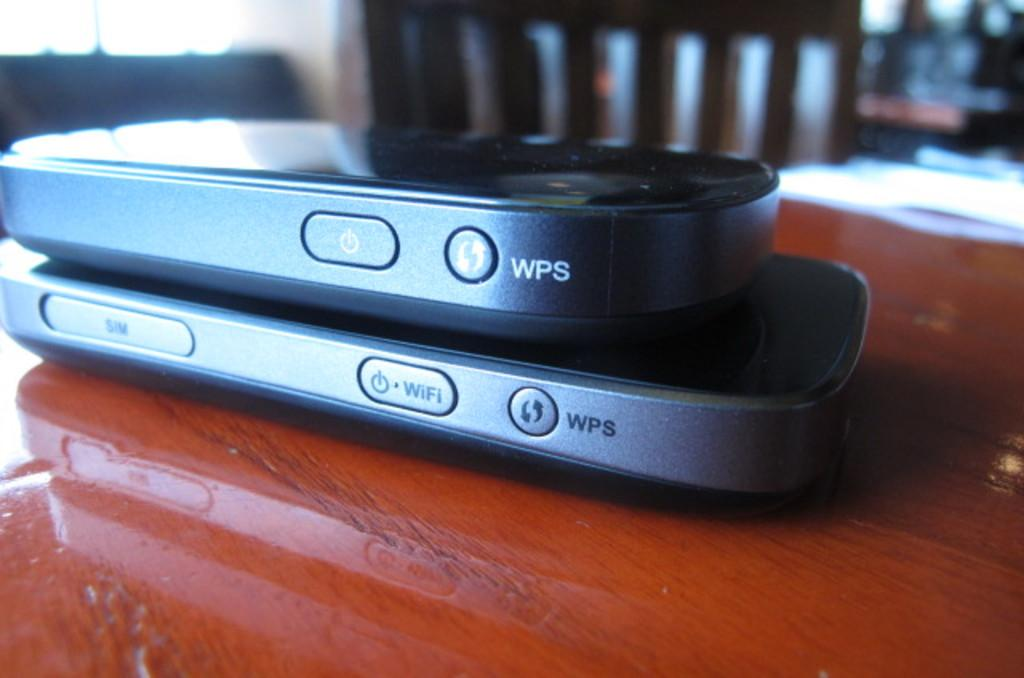<image>
Share a concise interpretation of the image provided. Two devices with WPS printed on their sides are shown on a wooden table. 